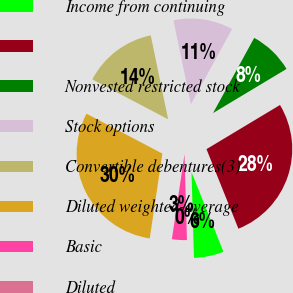<chart> <loc_0><loc_0><loc_500><loc_500><pie_chart><fcel>Income from continuing<fcel>Unnamed: 1<fcel>Nonvested restricted stock<fcel>Stock options<fcel>Convertible debentures(3)<fcel>Diluted weighted-average<fcel>Basic<fcel>Diluted<nl><fcel>5.62%<fcel>27.54%<fcel>8.42%<fcel>11.23%<fcel>14.04%<fcel>30.35%<fcel>2.81%<fcel>0.0%<nl></chart> 